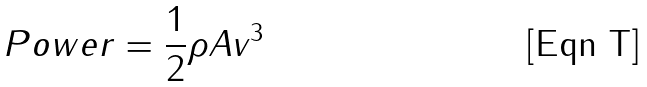<formula> <loc_0><loc_0><loc_500><loc_500>P o w e r = \frac { 1 } { 2 } \rho A v ^ { 3 }</formula> 